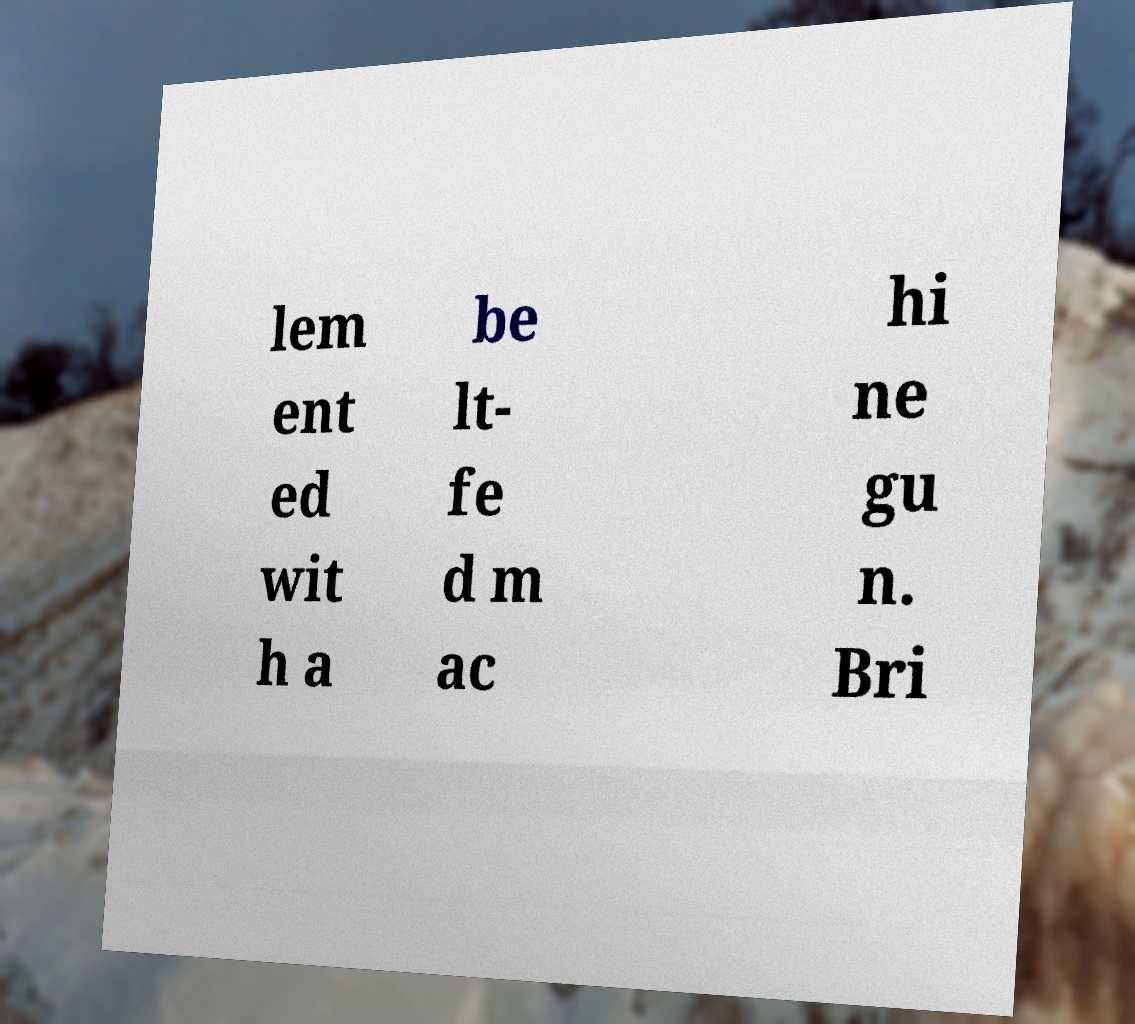Please identify and transcribe the text found in this image. lem ent ed wit h a be lt- fe d m ac hi ne gu n. Bri 